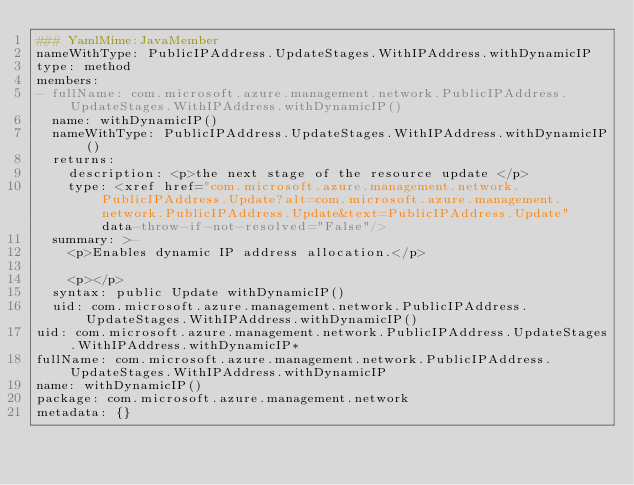Convert code to text. <code><loc_0><loc_0><loc_500><loc_500><_YAML_>### YamlMime:JavaMember
nameWithType: PublicIPAddress.UpdateStages.WithIPAddress.withDynamicIP
type: method
members:
- fullName: com.microsoft.azure.management.network.PublicIPAddress.UpdateStages.WithIPAddress.withDynamicIP()
  name: withDynamicIP()
  nameWithType: PublicIPAddress.UpdateStages.WithIPAddress.withDynamicIP()
  returns:
    description: <p>the next stage of the resource update </p>
    type: <xref href="com.microsoft.azure.management.network.PublicIPAddress.Update?alt=com.microsoft.azure.management.network.PublicIPAddress.Update&text=PublicIPAddress.Update" data-throw-if-not-resolved="False"/>
  summary: >-
    <p>Enables dynamic IP address allocation.</p>

    <p></p>
  syntax: public Update withDynamicIP()
  uid: com.microsoft.azure.management.network.PublicIPAddress.UpdateStages.WithIPAddress.withDynamicIP()
uid: com.microsoft.azure.management.network.PublicIPAddress.UpdateStages.WithIPAddress.withDynamicIP*
fullName: com.microsoft.azure.management.network.PublicIPAddress.UpdateStages.WithIPAddress.withDynamicIP
name: withDynamicIP()
package: com.microsoft.azure.management.network
metadata: {}
</code> 